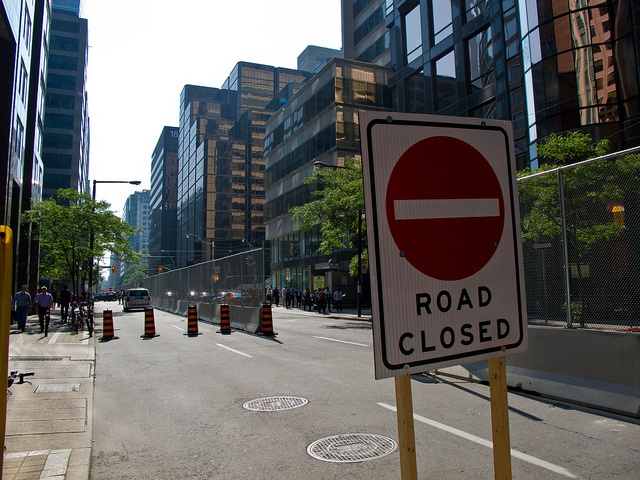Describe the objects in this image and their specific colors. I can see people in black and gray tones, car in black, gray, navy, and purple tones, people in black, navy, and gray tones, car in black, gray, and purple tones, and bicycle in black, darkgray, gray, and purple tones in this image. 